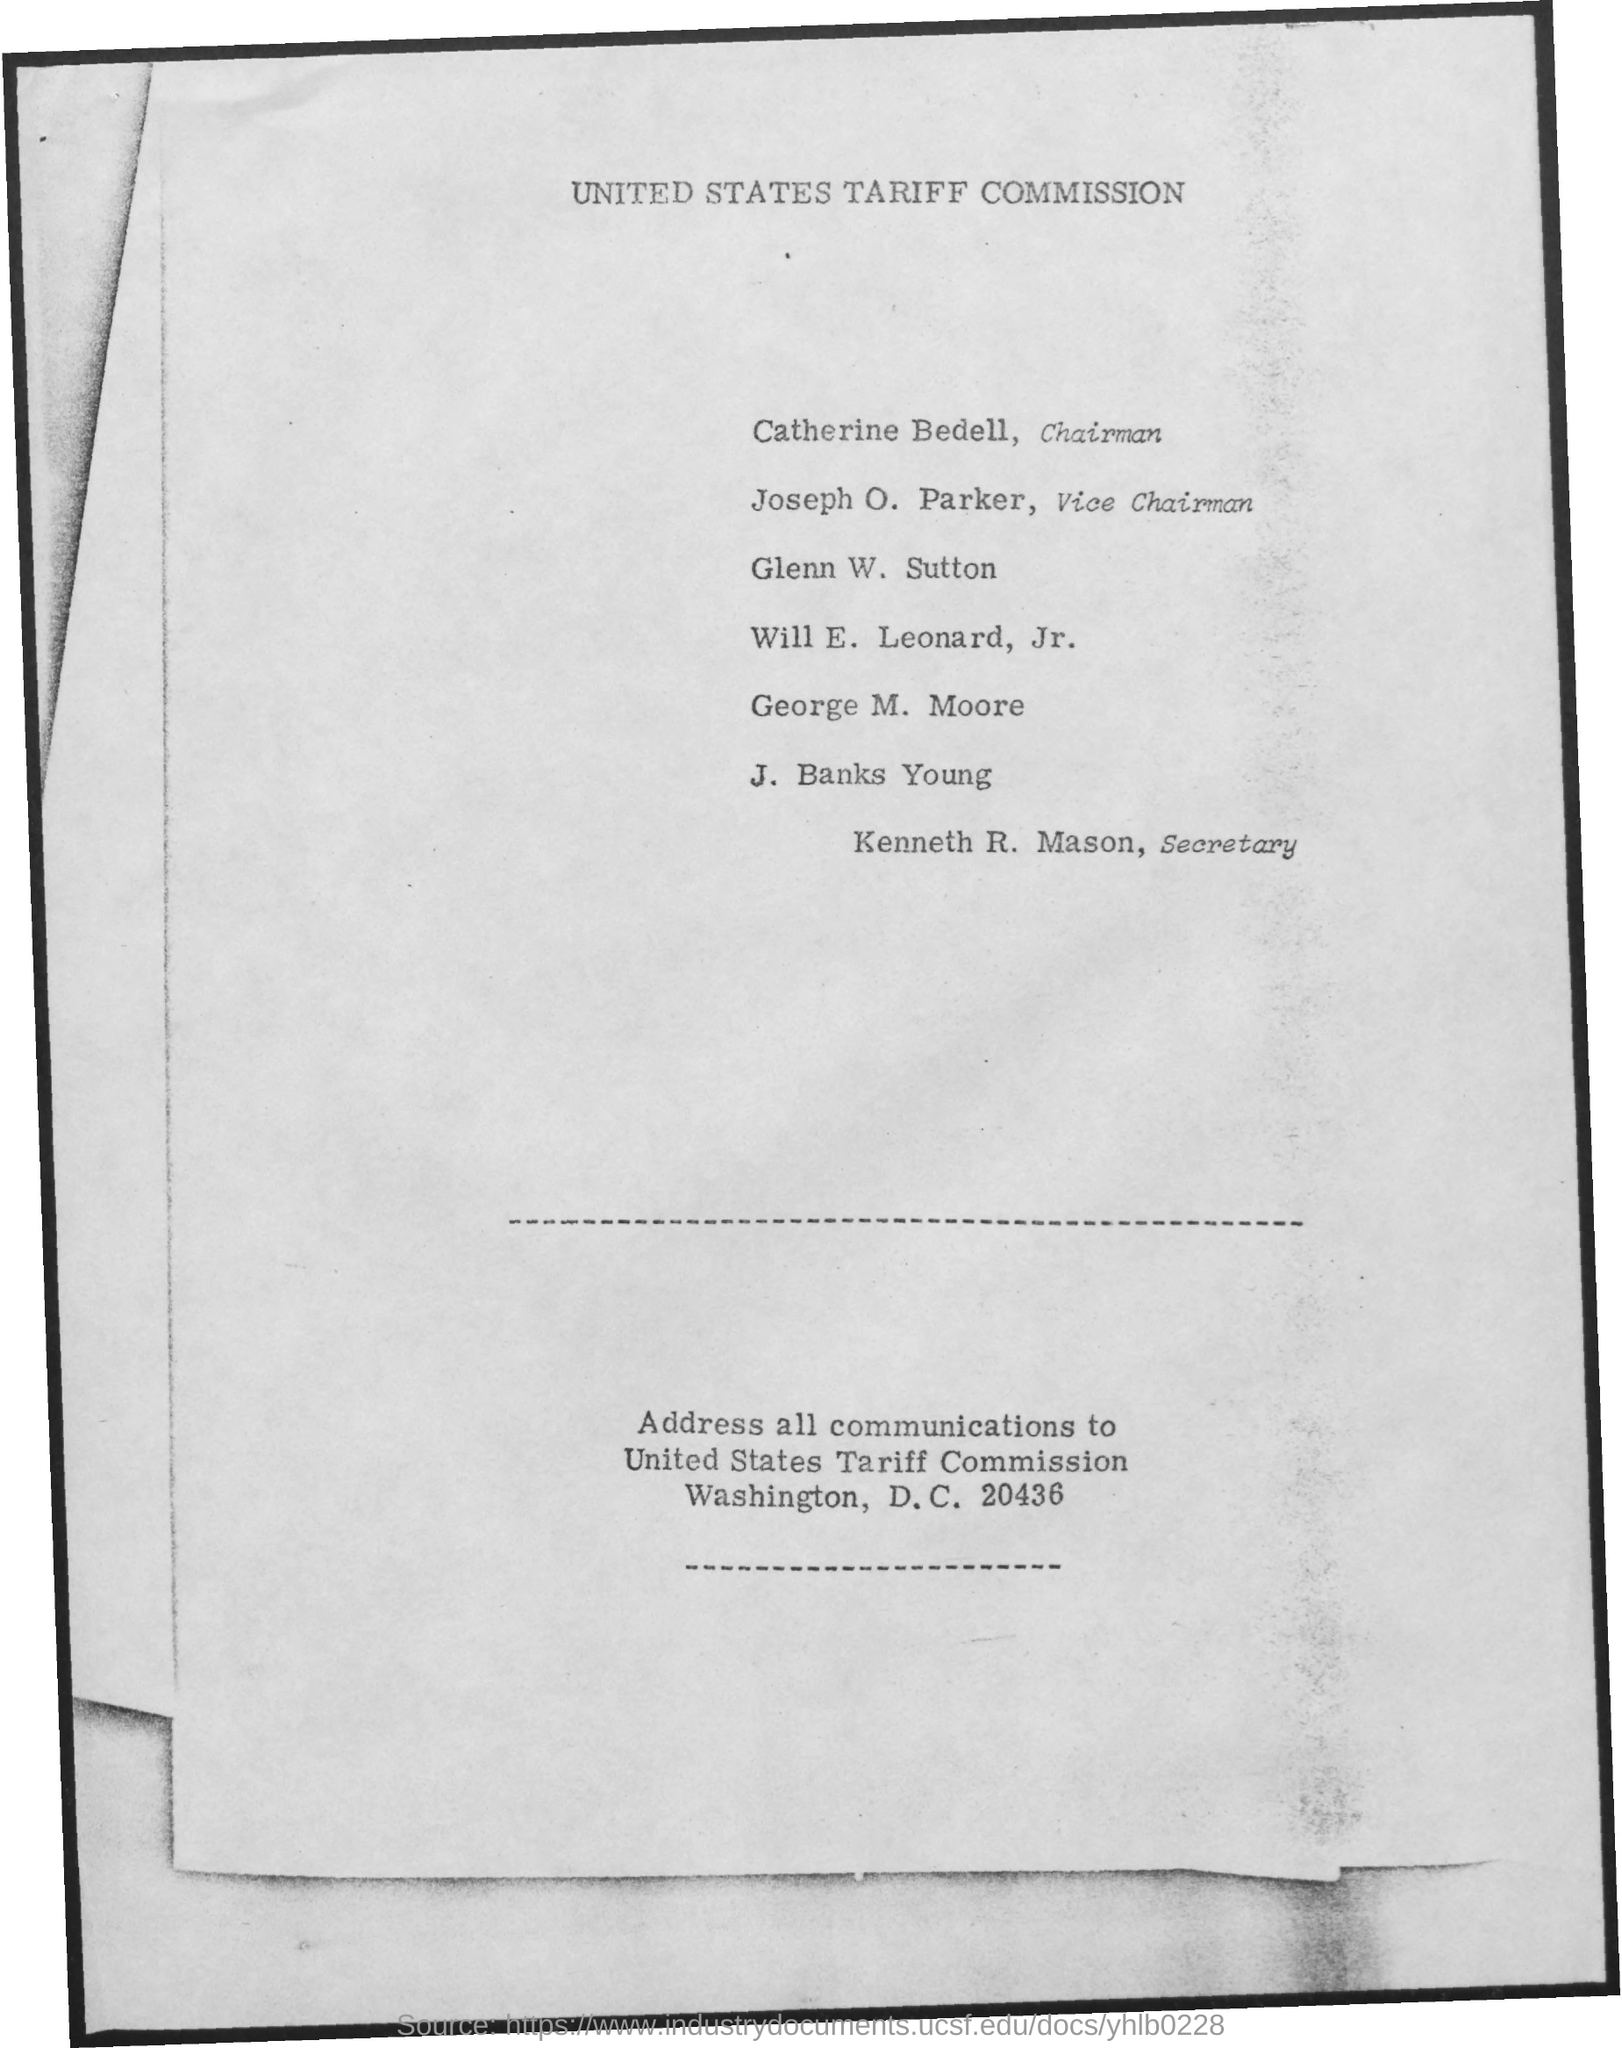Draw attention to some important aspects in this diagram. The secretary's name is Kenneth R. Mason. The chairman's name is Catherine Bedell. The name of the commission mentioned is the United States Tariff Commission. The name of the vice chairman mentioned is Joseph O. Parker. 